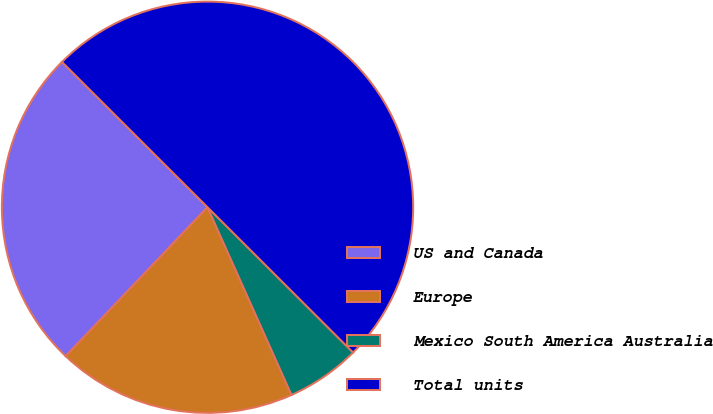<chart> <loc_0><loc_0><loc_500><loc_500><pie_chart><fcel>US and Canada<fcel>Europe<fcel>Mexico South America Australia<fcel>Total units<nl><fcel>25.37%<fcel>18.81%<fcel>5.82%<fcel>50.0%<nl></chart> 